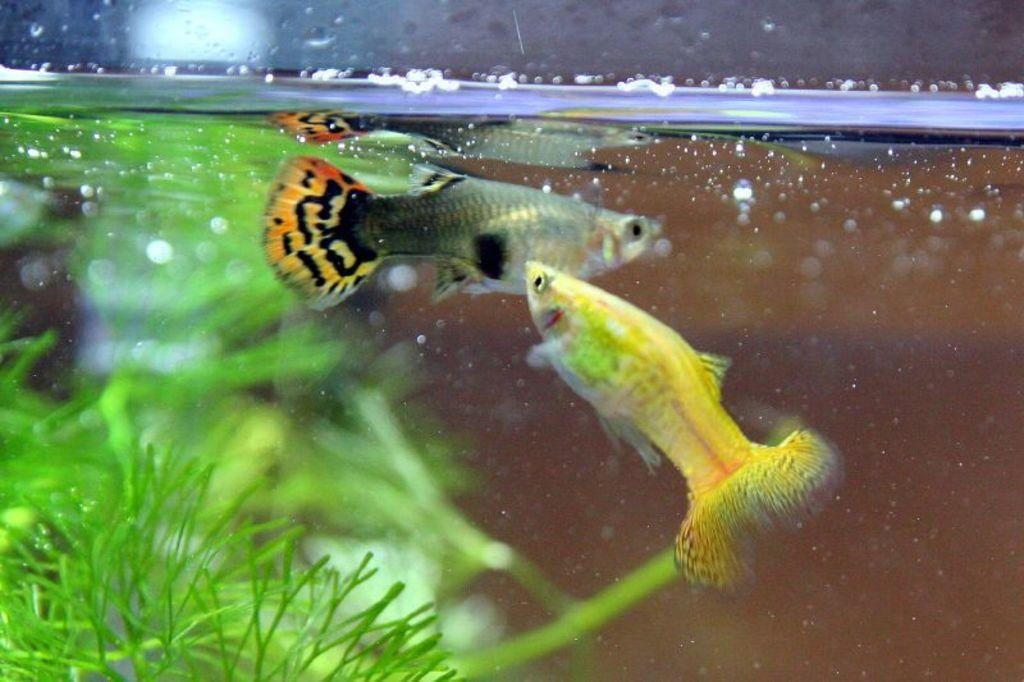What animals can be seen in the water in the image? There are two beautiful fishes in the water in the image. Where is the water located? The water is in an aquarium. What can be seen on the left side of the image? There are green leaves on the left side of the image. Where is the play taking place in the image? There is no play or any indication of a play taking place in the image. 